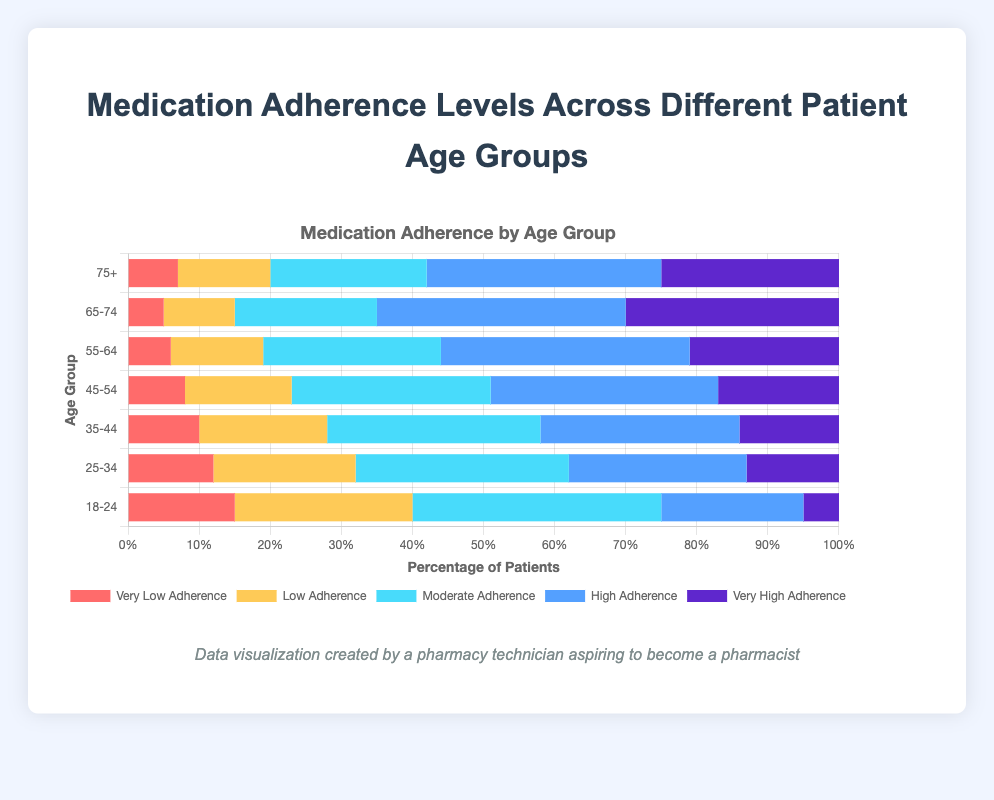What is the highest adherence level among age group 18-24? The adherence levels are given as percentages stacked horizontally. For the age group 18-24, the bar with the greatest length represents the Moderate Adherence level at 35%.
Answer: Moderate Adherence Which age group has the highest percentage of Very High Adherence? By visual inspection, the bar for the age group 65-74 has the largest portion of dark blue color, which represents Very High Adherence at 30%.
Answer: 65-74 What is the difference in High Adherence percentage between age groups 55-64 and 35-44? High Adherence for 55-64 is 35% and for 35-44 is 28%. The difference is calculated as 35% - 28% = 7%.
Answer: 7% Among the age groups 35-44 and 45-54, which has a higher combined percentage of Low and Moderate Adherence? For 35-44, Low Adherence is 18% and Moderate Adherence is 30%. Combined, this is 18% + 30% = 48%. For 45-54, Low Adherence is 15% and Moderate Adherence is 28%. Combined, this is 15% + 28% = 43%. Thus, 35-44 has a higher combined percentage of Low and Moderate Adherence.
Answer: 35-44 How much greater is the Moderate Adherence percentage compared to the Low Adherence percentage for the age group 25-34? For age group 25-34, Moderate Adherence is 30% and Low Adherence is 20%. Difference is 30% - 20% = 10%.
Answer: 10% What is the combined percentage of High and Very High Adherence for age group 75+? High Adherence for 75+ is 33% and Very High Adherence is 25%. Combined, this is 33% + 25% = 58%.
Answer: 58% Which age group has the lowest percentage of Very Low Adherence and what is it? The shortest red bar represents 65-74, where Very Low Adherence is 5%.
Answer: 65-74, 5% In the age groups 55-64 and 65-74, what is the average percentage of Moderate Adherence? Moderate Adherence for 55-64 is 25% and for 65-74 is 20%. The average is (25% + 20%) / 2 = 22.5%.
Answer: 22.5% Between age groups 18-24 and 25-34, which has a higher percentage of Low Adherence and by how much? Low Adherence for 18-24 is 25% and for 25-34 is 20%. Difference is 25% - 20% = 5%. Age group 18-24 has a higher percentage by 5%.
Answer: 18-24, 5% 